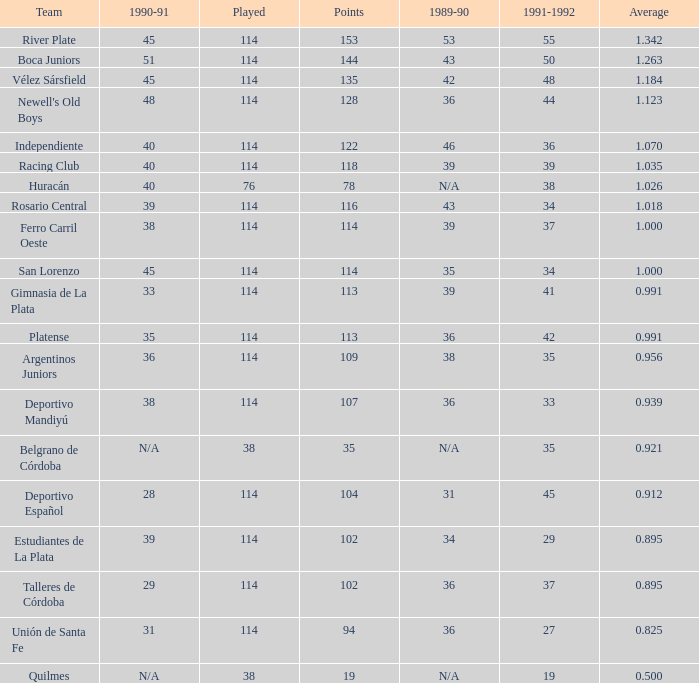How much Average has a 1989-90 of 36, and a Team of talleres de córdoba, and a Played smaller than 114? 0.0. 